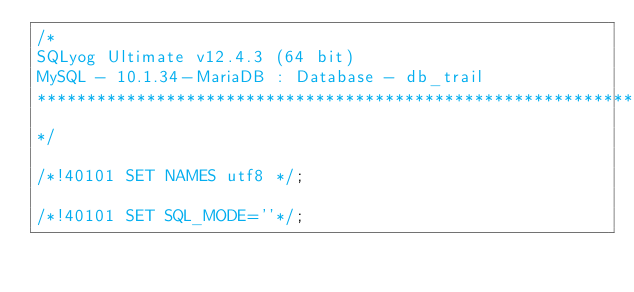Convert code to text. <code><loc_0><loc_0><loc_500><loc_500><_SQL_>/*
SQLyog Ultimate v12.4.3 (64 bit)
MySQL - 10.1.34-MariaDB : Database - db_trail
*********************************************************************
*/

/*!40101 SET NAMES utf8 */;

/*!40101 SET SQL_MODE=''*/;
</code> 